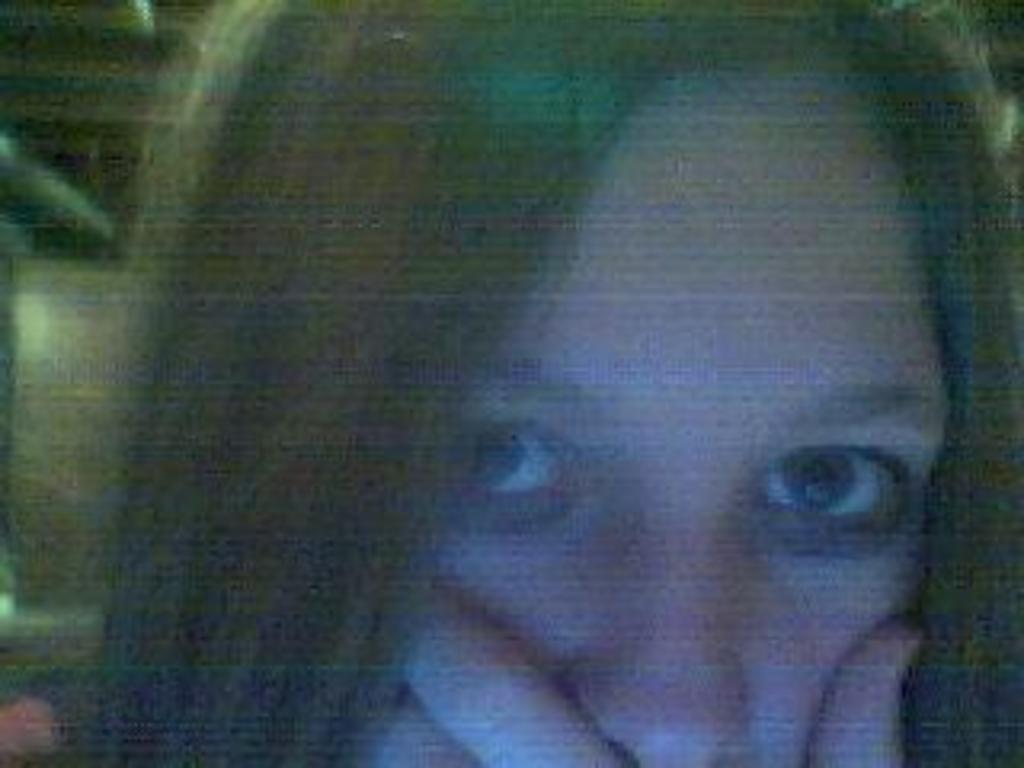Can you describe this image briefly? This image consists of a girl. And the background is blurred. 